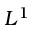Convert formula to latex. <formula><loc_0><loc_0><loc_500><loc_500>L ^ { 1 }</formula> 